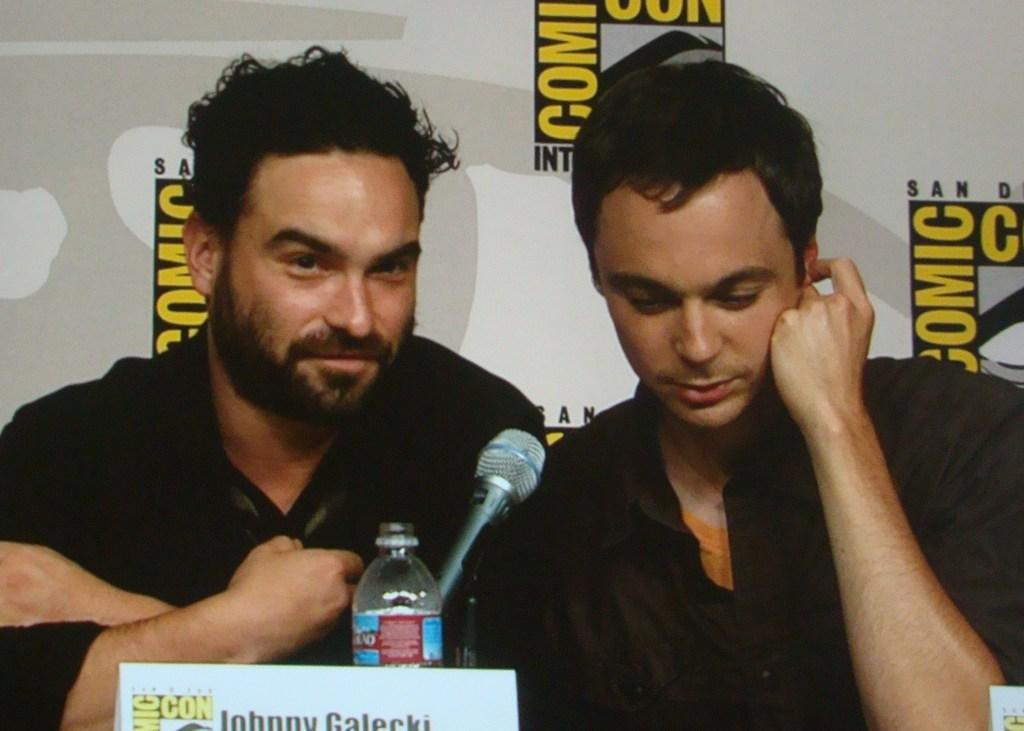How many people are in the image? There are two men in the image. What are the men doing in the image? The men are seated in the image. What objects are in front of the men? There is a microphone, a bottle, and a name board in front of the men. What can be seen in the background of the image? There is a hoarding in the background of the image. What type of shirt is the man on the left wearing in the image? There is no information about the shirt the man on the left is wearing in the image. What is the purpose of the stop sign in the image? There is no stop sign present in the image. 